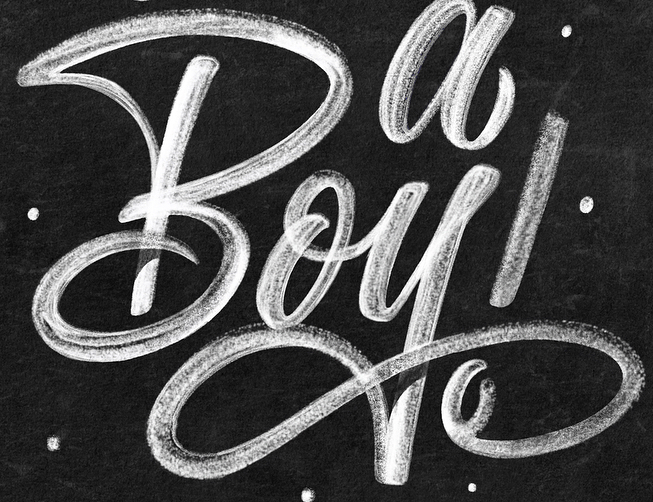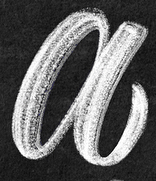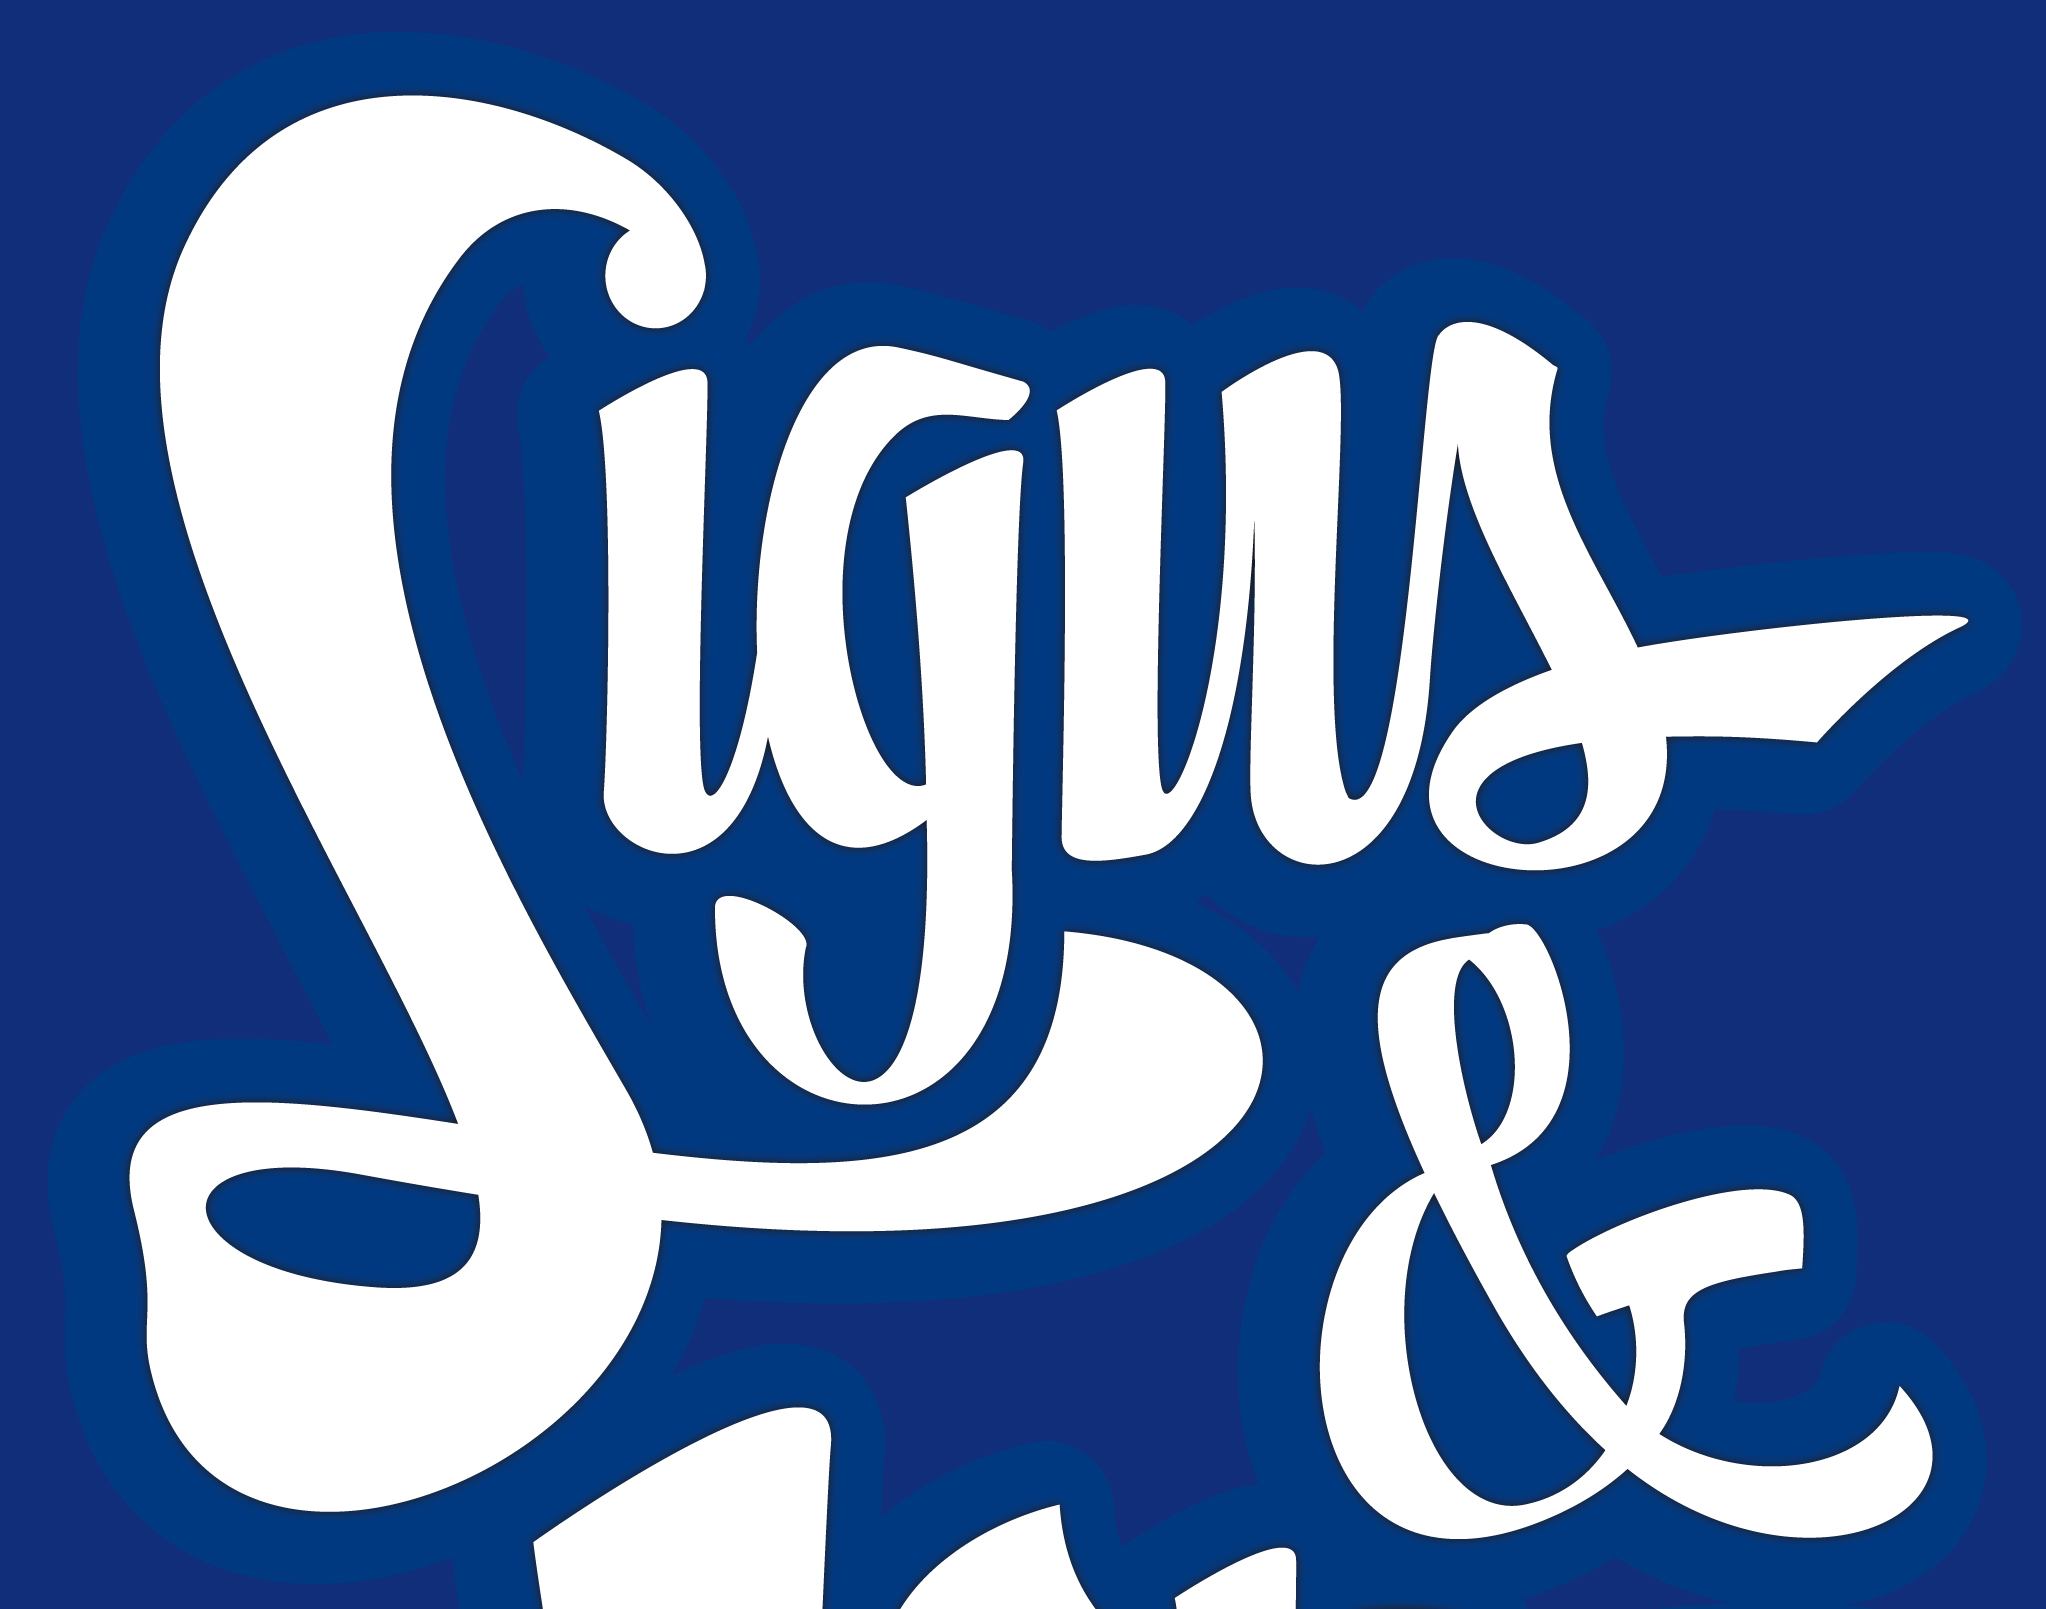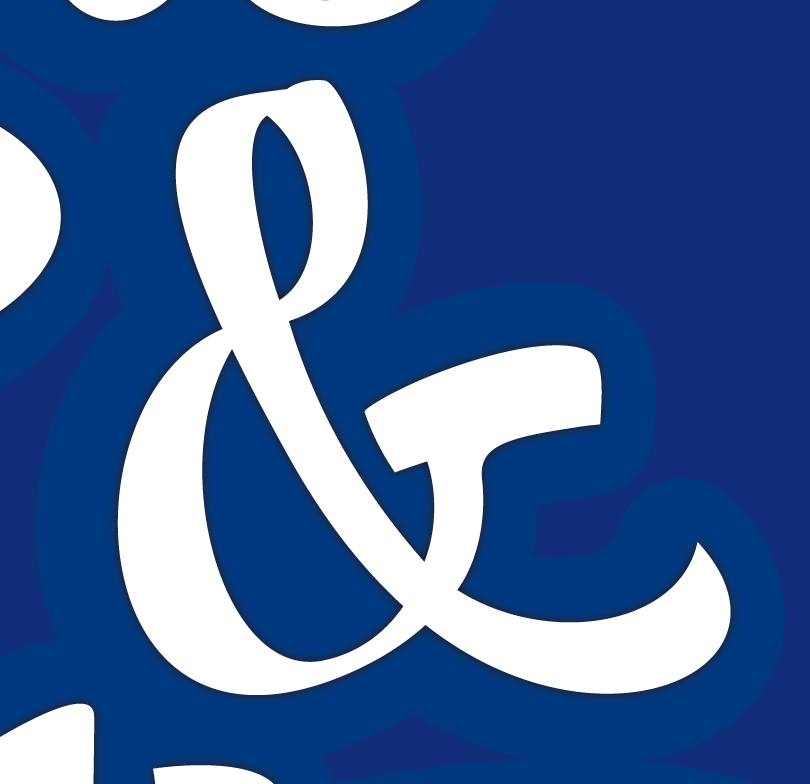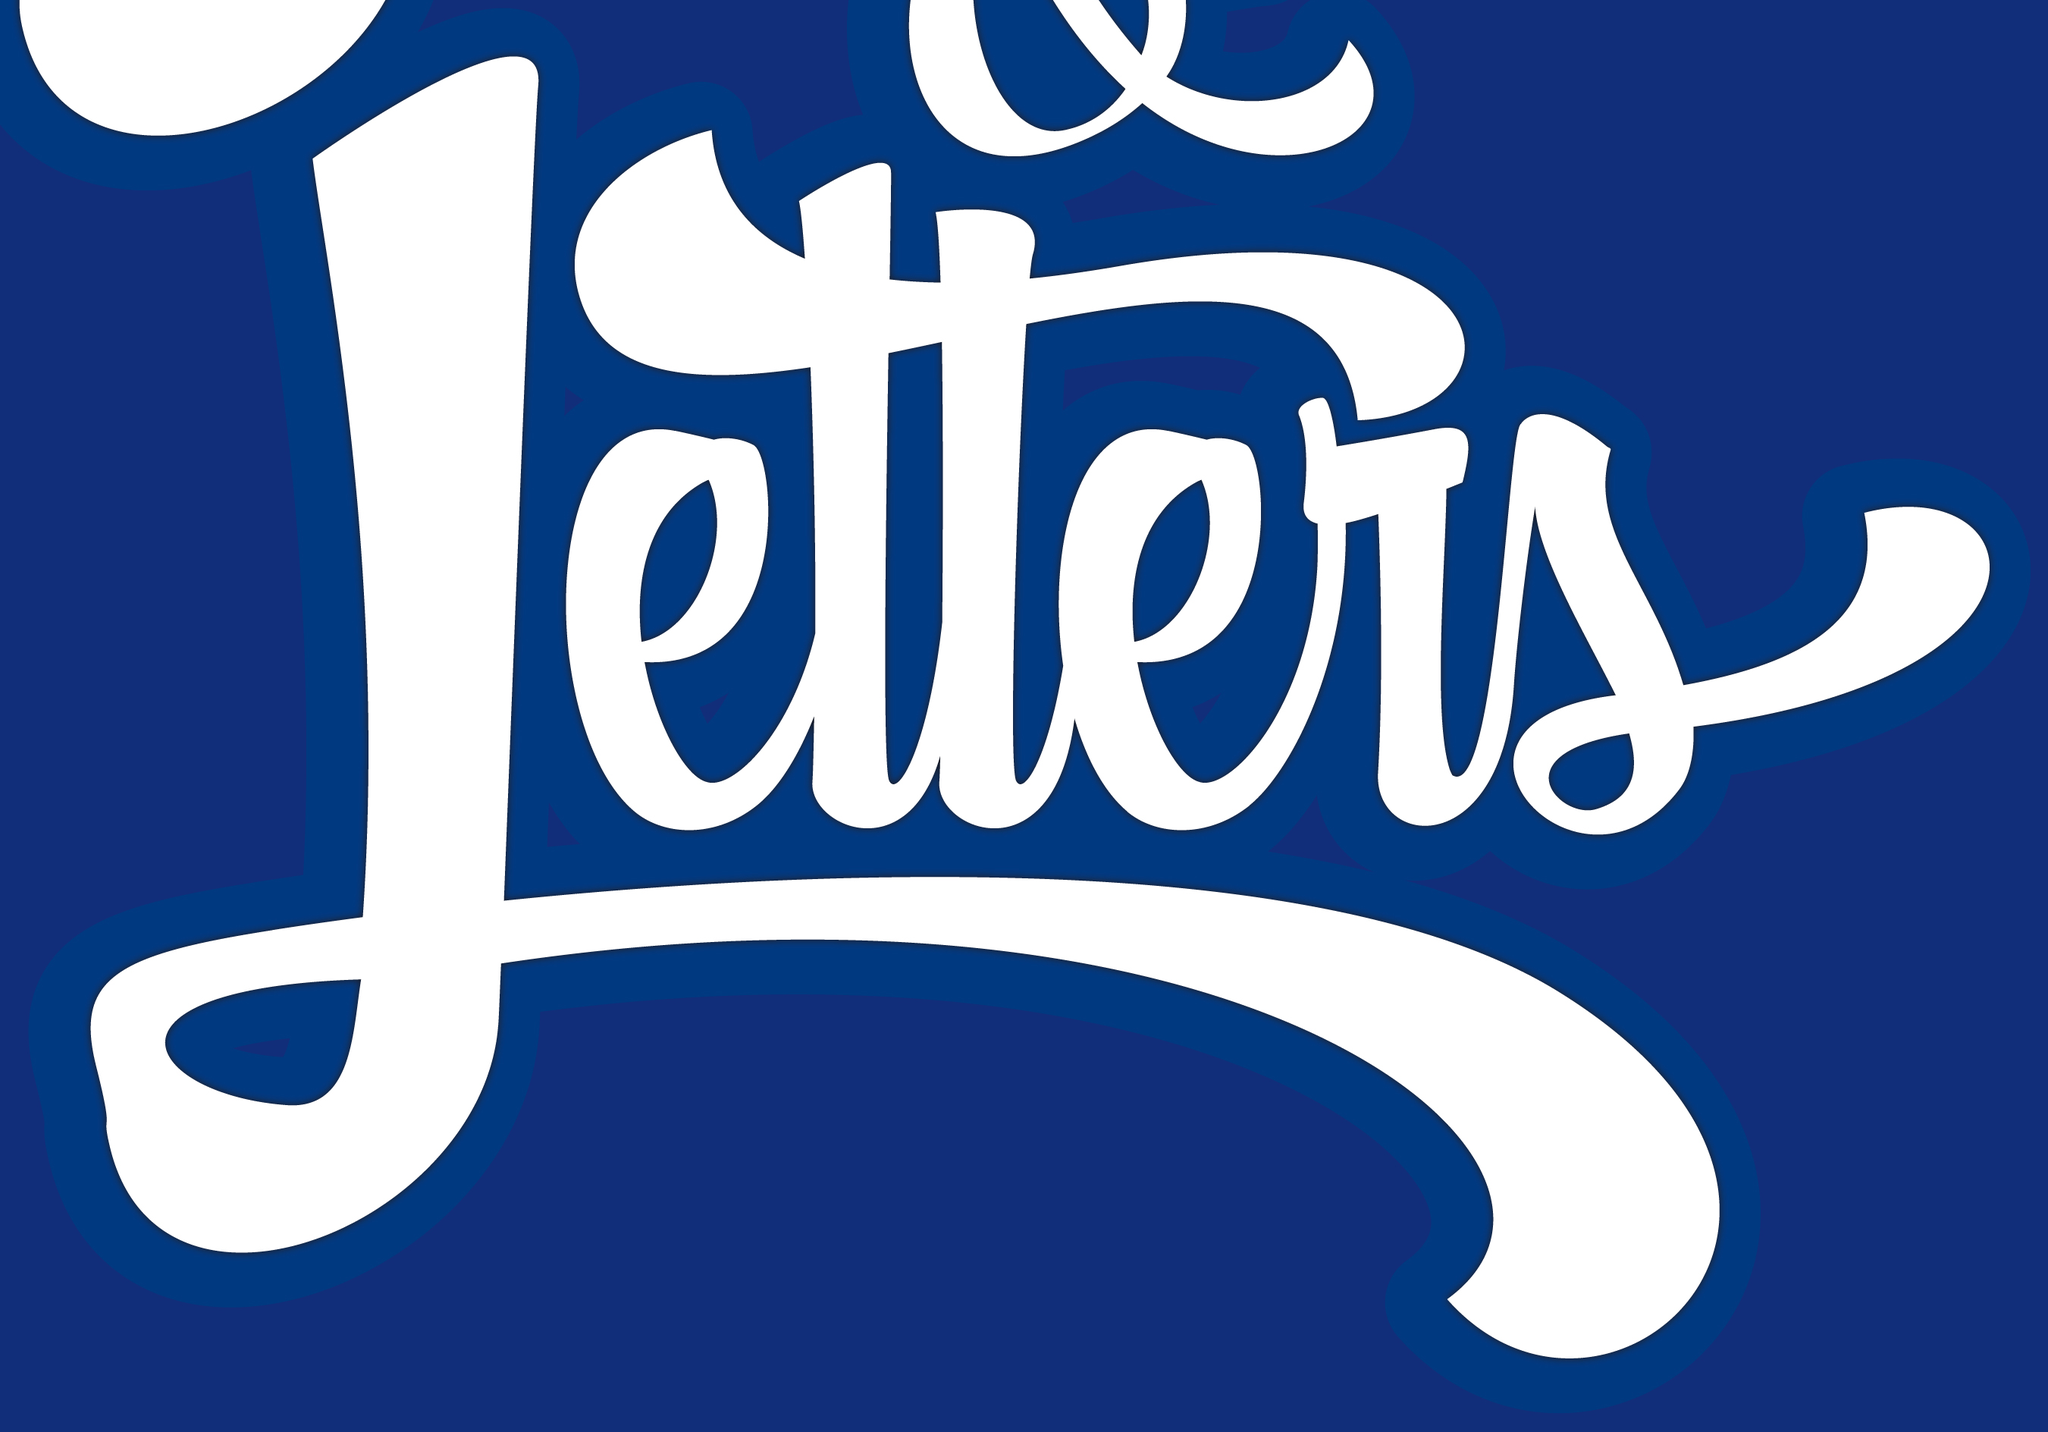Read the text from these images in sequence, separated by a semicolon. Boy!; a; Signs; &; Letters 